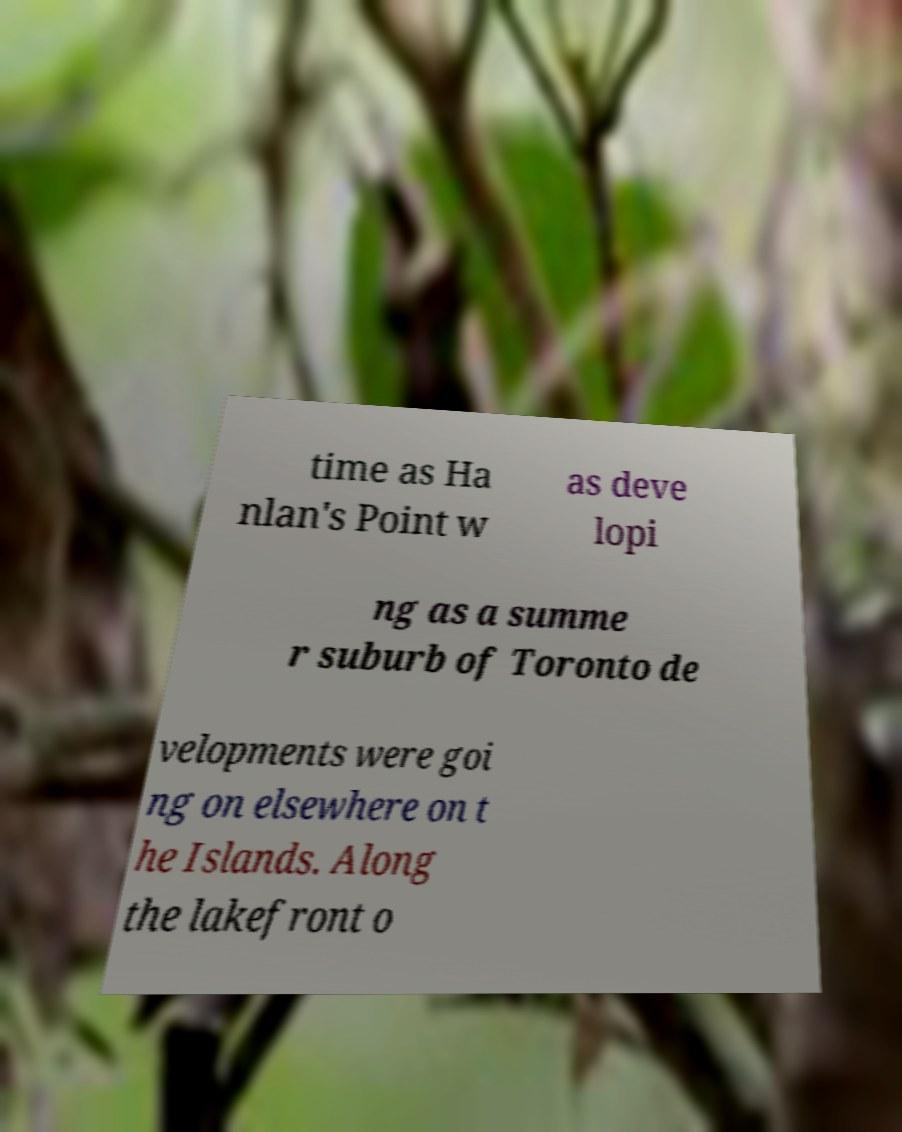Could you assist in decoding the text presented in this image and type it out clearly? time as Ha nlan's Point w as deve lopi ng as a summe r suburb of Toronto de velopments were goi ng on elsewhere on t he Islands. Along the lakefront o 